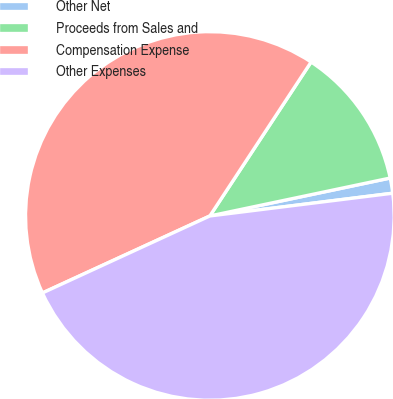Convert chart. <chart><loc_0><loc_0><loc_500><loc_500><pie_chart><fcel>Other Net<fcel>Proceeds from Sales and<fcel>Compensation Expense<fcel>Other Expenses<nl><fcel>1.33%<fcel>12.44%<fcel>41.12%<fcel>45.11%<nl></chart> 